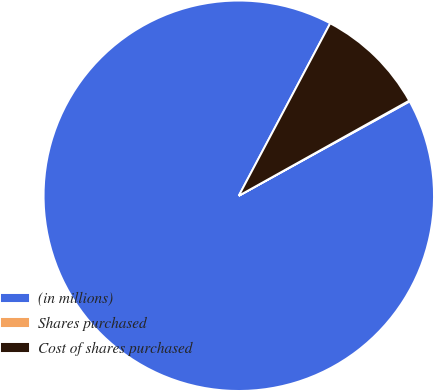<chart> <loc_0><loc_0><loc_500><loc_500><pie_chart><fcel>(in millions)<fcel>Shares purchased<fcel>Cost of shares purchased<nl><fcel>90.79%<fcel>0.07%<fcel>9.14%<nl></chart> 